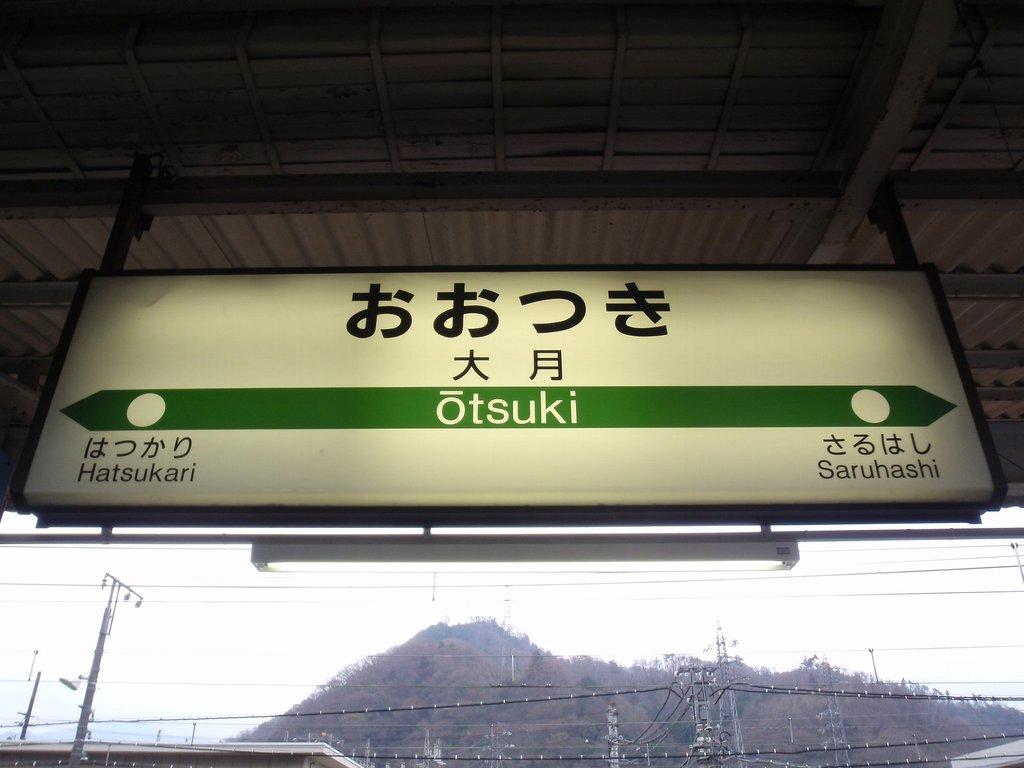Which name sounds similar to a true blood character?
Your response must be concise. Otsuki. 